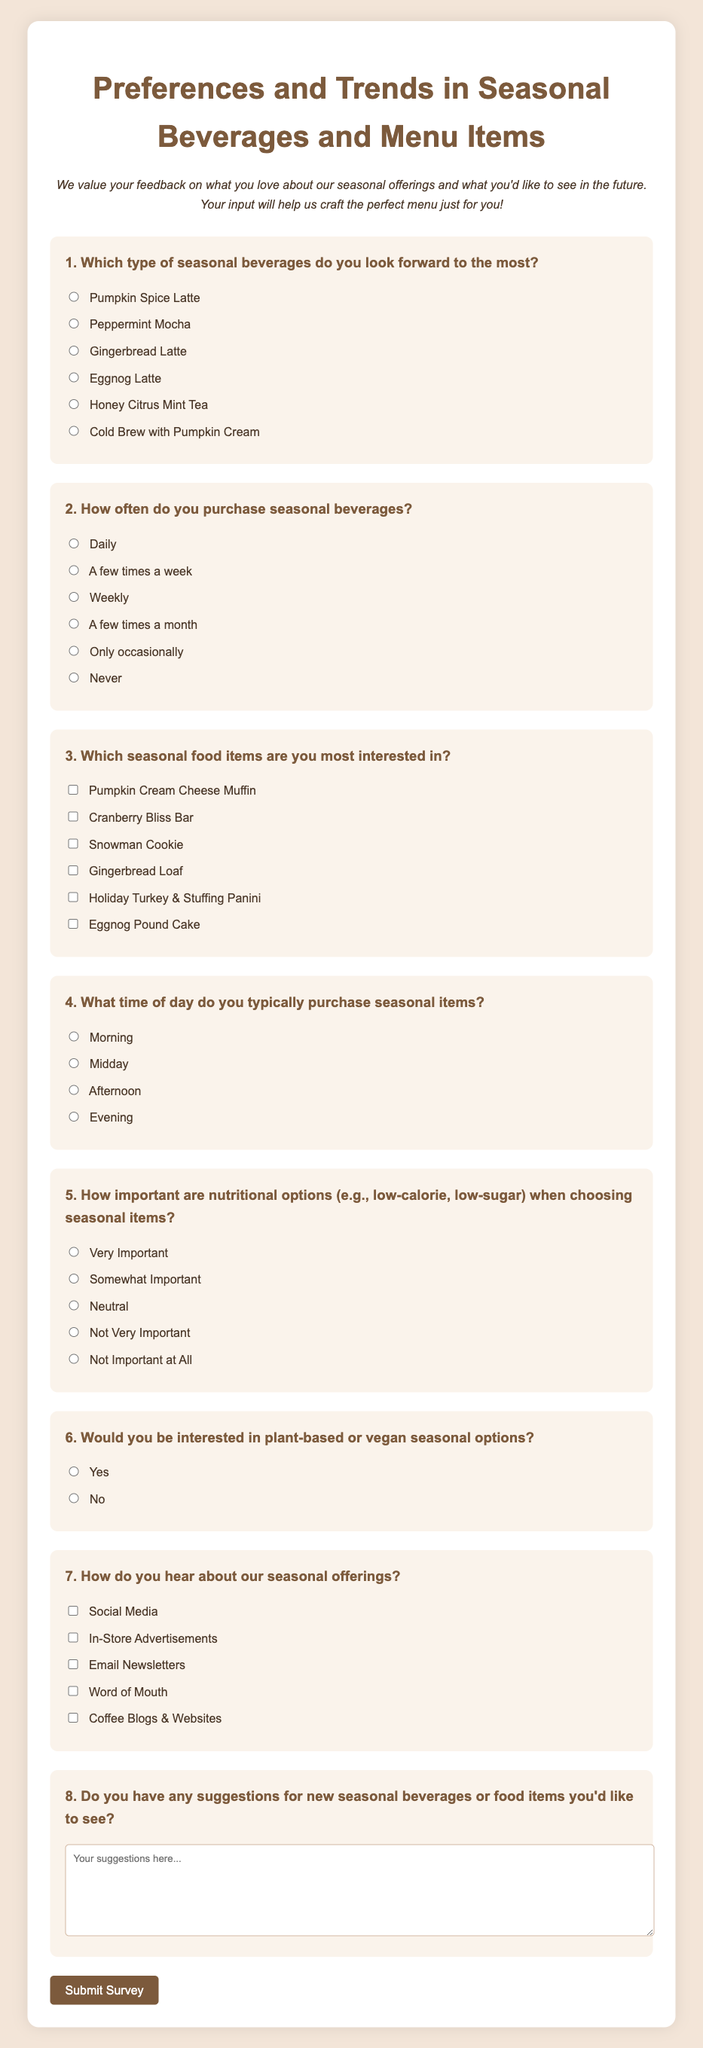What is the title of the survey? The title of the survey is the main heading centered at the top of the document.
Answer: Preferences and Trends in Seasonal Beverages and Menu Items What is the first question in the survey? The first question is the first prompt in the survey, asking about seasonal beverage preferences.
Answer: Which type of seasonal beverages do you look forward to the most? How many options are provided for the second question? The number of options can be counted from the list of radio buttons under the second question.
Answer: 6 What type of items does the third question ask about? The third question prompts the respondent to select items from a specific category.
Answer: Seasonal food items How is the importance of nutritional options rated in the survey? The fifth question provides a scale for respondents to express the significance of nutritional options.
Answer: Very Important to Not Important at All What is the question type for the seventh question? This question can be identified based on the format of the options presented in the document.
Answer: Checkbox How do respondents submit their answers? The method of submission is identified by the action associated with the button in the form.
Answer: Click the Submit Survey button What is requested in the eighth question? The eighth question asks for a specific type of feedback from the respondents.
Answer: Suggestions for new seasonal beverages or food items 